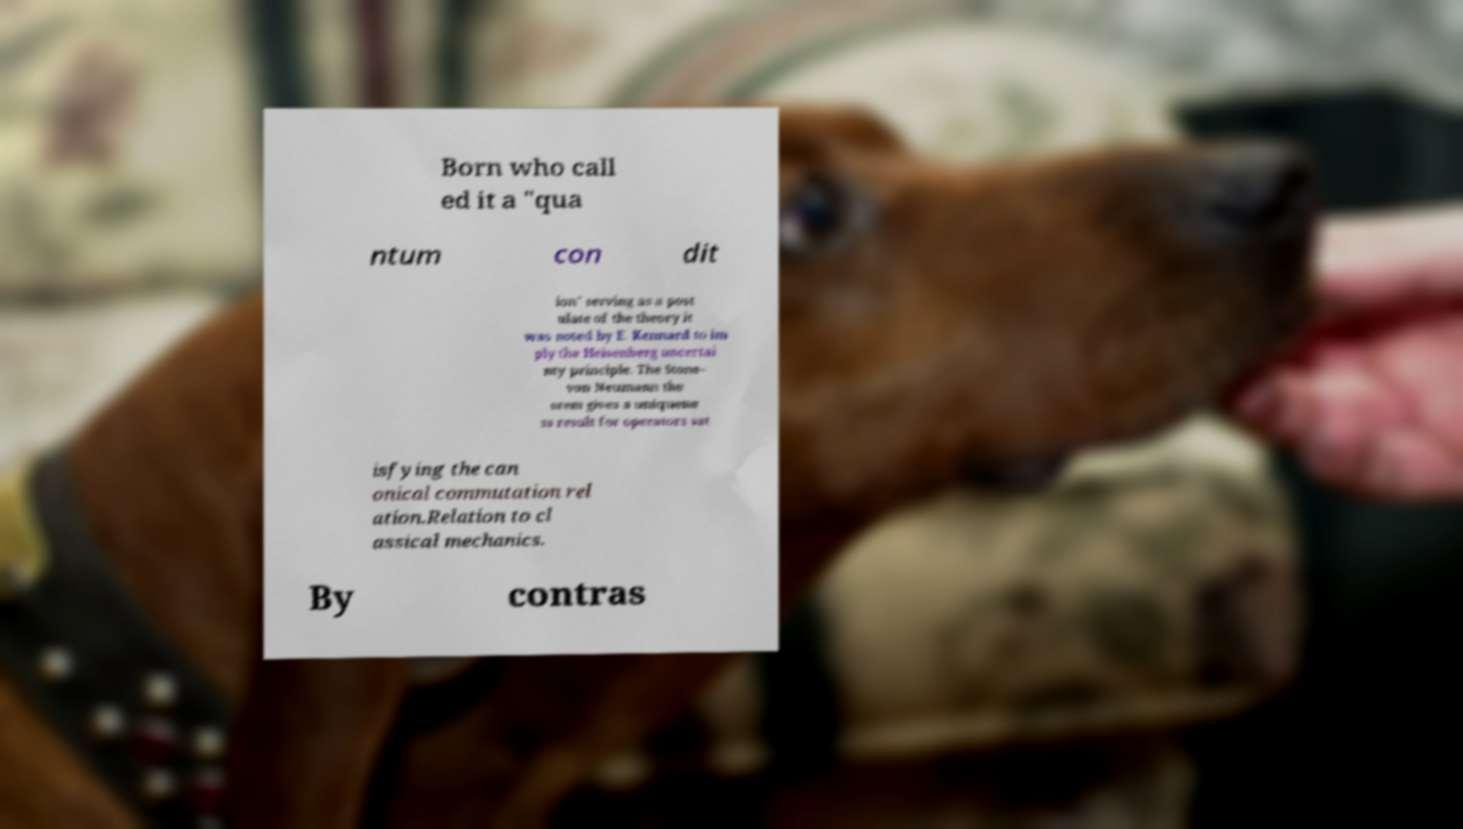Please read and relay the text visible in this image. What does it say? Born who call ed it a "qua ntum con dit ion" serving as a post ulate of the theory it was noted by E. Kennard to im ply the Heisenberg uncertai nty principle. The Stone– von Neumann the orem gives a uniquene ss result for operators sat isfying the can onical commutation rel ation.Relation to cl assical mechanics. By contras 